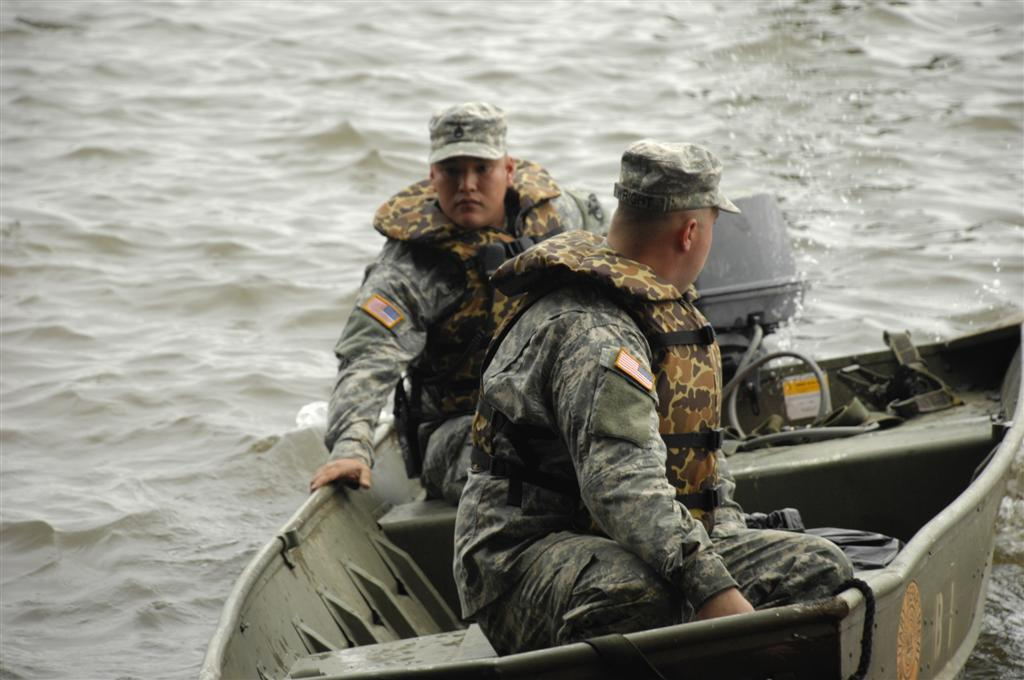How many people are in the image? There are two persons in the image. What are the two persons doing in the image? The two persons are sitting in a boat. Where is the boat located in the image? The boat is on the water. What type of clothing are the two persons wearing? The two persons are wearing military dresses. What type of lipstick is the person in the boat wearing? There is no indication of lipstick or any cosmetics in the image, as the two persons are wearing military dresses. 